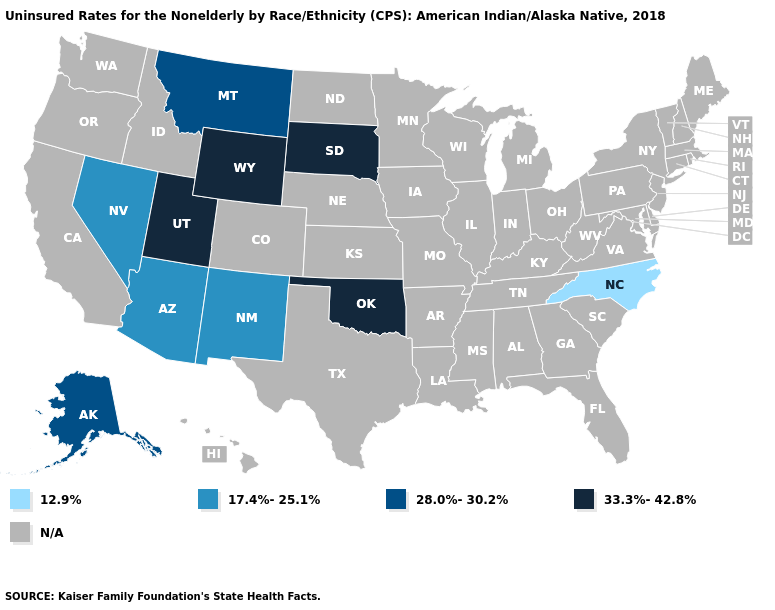Name the states that have a value in the range N/A?
Write a very short answer. Alabama, Arkansas, California, Colorado, Connecticut, Delaware, Florida, Georgia, Hawaii, Idaho, Illinois, Indiana, Iowa, Kansas, Kentucky, Louisiana, Maine, Maryland, Massachusetts, Michigan, Minnesota, Mississippi, Missouri, Nebraska, New Hampshire, New Jersey, New York, North Dakota, Ohio, Oregon, Pennsylvania, Rhode Island, South Carolina, Tennessee, Texas, Vermont, Virginia, Washington, West Virginia, Wisconsin. What is the value of Minnesota?
Answer briefly. N/A. What is the value of Louisiana?
Write a very short answer. N/A. Does the map have missing data?
Write a very short answer. Yes. Which states have the lowest value in the MidWest?
Short answer required. South Dakota. What is the value of Nevada?
Short answer required. 17.4%-25.1%. Name the states that have a value in the range 33.3%-42.8%?
Concise answer only. Oklahoma, South Dakota, Utah, Wyoming. Is the legend a continuous bar?
Answer briefly. No. How many symbols are there in the legend?
Quick response, please. 5. Which states hav the highest value in the West?
Concise answer only. Utah, Wyoming. What is the value of New Jersey?
Be succinct. N/A. Name the states that have a value in the range 33.3%-42.8%?
Answer briefly. Oklahoma, South Dakota, Utah, Wyoming. What is the value of Minnesota?
Short answer required. N/A. 